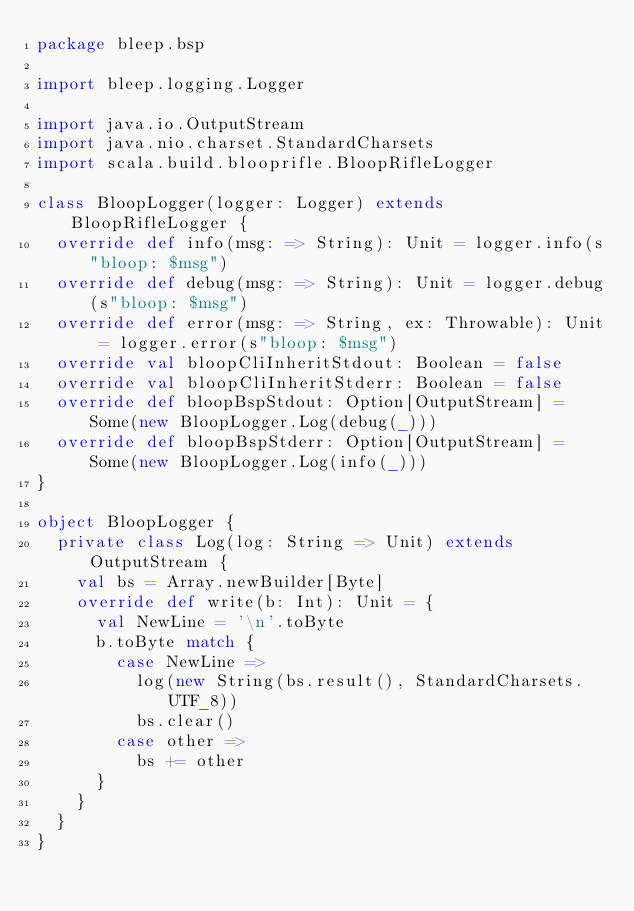Convert code to text. <code><loc_0><loc_0><loc_500><loc_500><_Scala_>package bleep.bsp

import bleep.logging.Logger

import java.io.OutputStream
import java.nio.charset.StandardCharsets
import scala.build.blooprifle.BloopRifleLogger

class BloopLogger(logger: Logger) extends BloopRifleLogger {
  override def info(msg: => String): Unit = logger.info(s"bloop: $msg")
  override def debug(msg: => String): Unit = logger.debug(s"bloop: $msg")
  override def error(msg: => String, ex: Throwable): Unit = logger.error(s"bloop: $msg")
  override val bloopCliInheritStdout: Boolean = false
  override val bloopCliInheritStderr: Boolean = false
  override def bloopBspStdout: Option[OutputStream] = Some(new BloopLogger.Log(debug(_)))
  override def bloopBspStderr: Option[OutputStream] = Some(new BloopLogger.Log(info(_)))
}

object BloopLogger {
  private class Log(log: String => Unit) extends OutputStream {
    val bs = Array.newBuilder[Byte]
    override def write(b: Int): Unit = {
      val NewLine = '\n'.toByte
      b.toByte match {
        case NewLine =>
          log(new String(bs.result(), StandardCharsets.UTF_8))
          bs.clear()
        case other =>
          bs += other
      }
    }
  }
}
</code> 